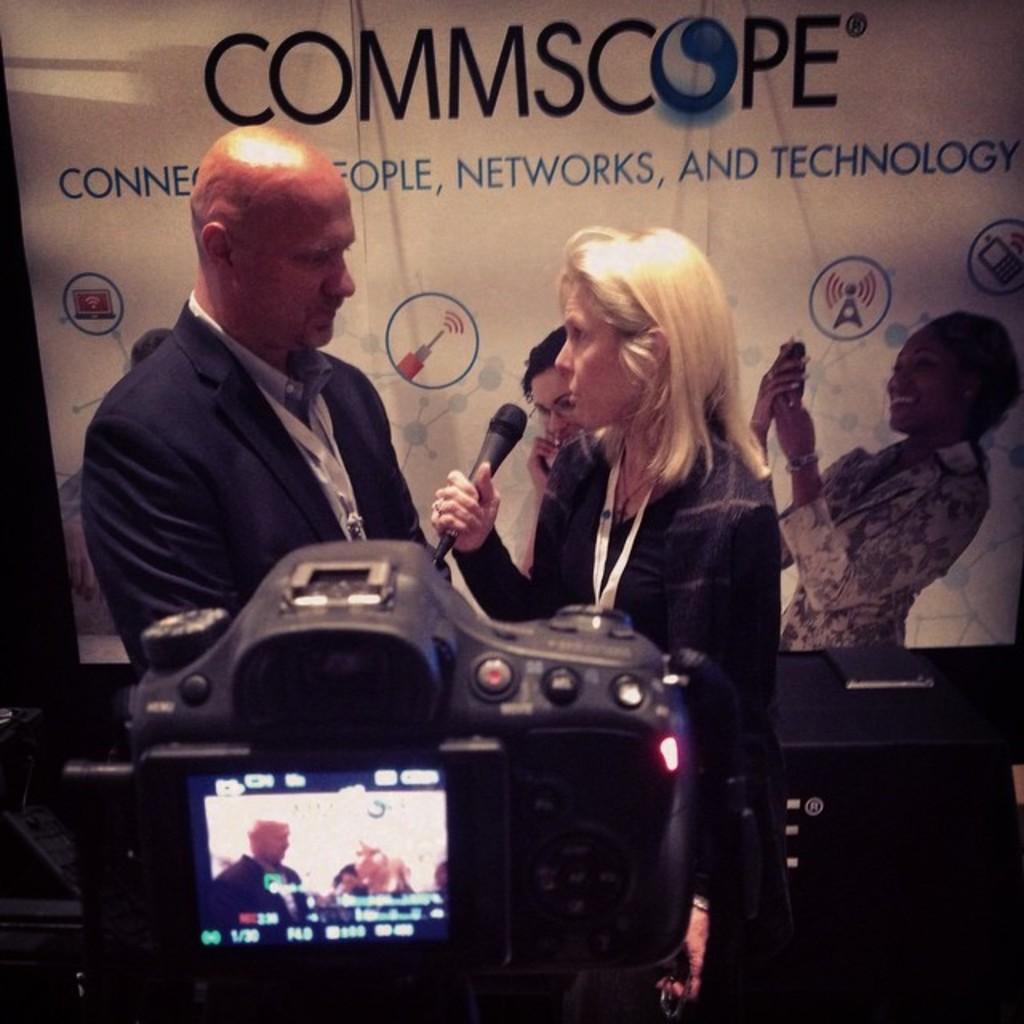Who are the people in the image? There is a man and a woman in the image. What is the woman holding in the image? The woman is holding a microphone. What are the man and the woman doing in the image? Both the man and the woman are standing in front of a camera. What can be seen in the background of the image? There is a banner in the background of the image. How does the man's vein appear in the image? There is no mention of the man's vein in the image, so it cannot be described. 